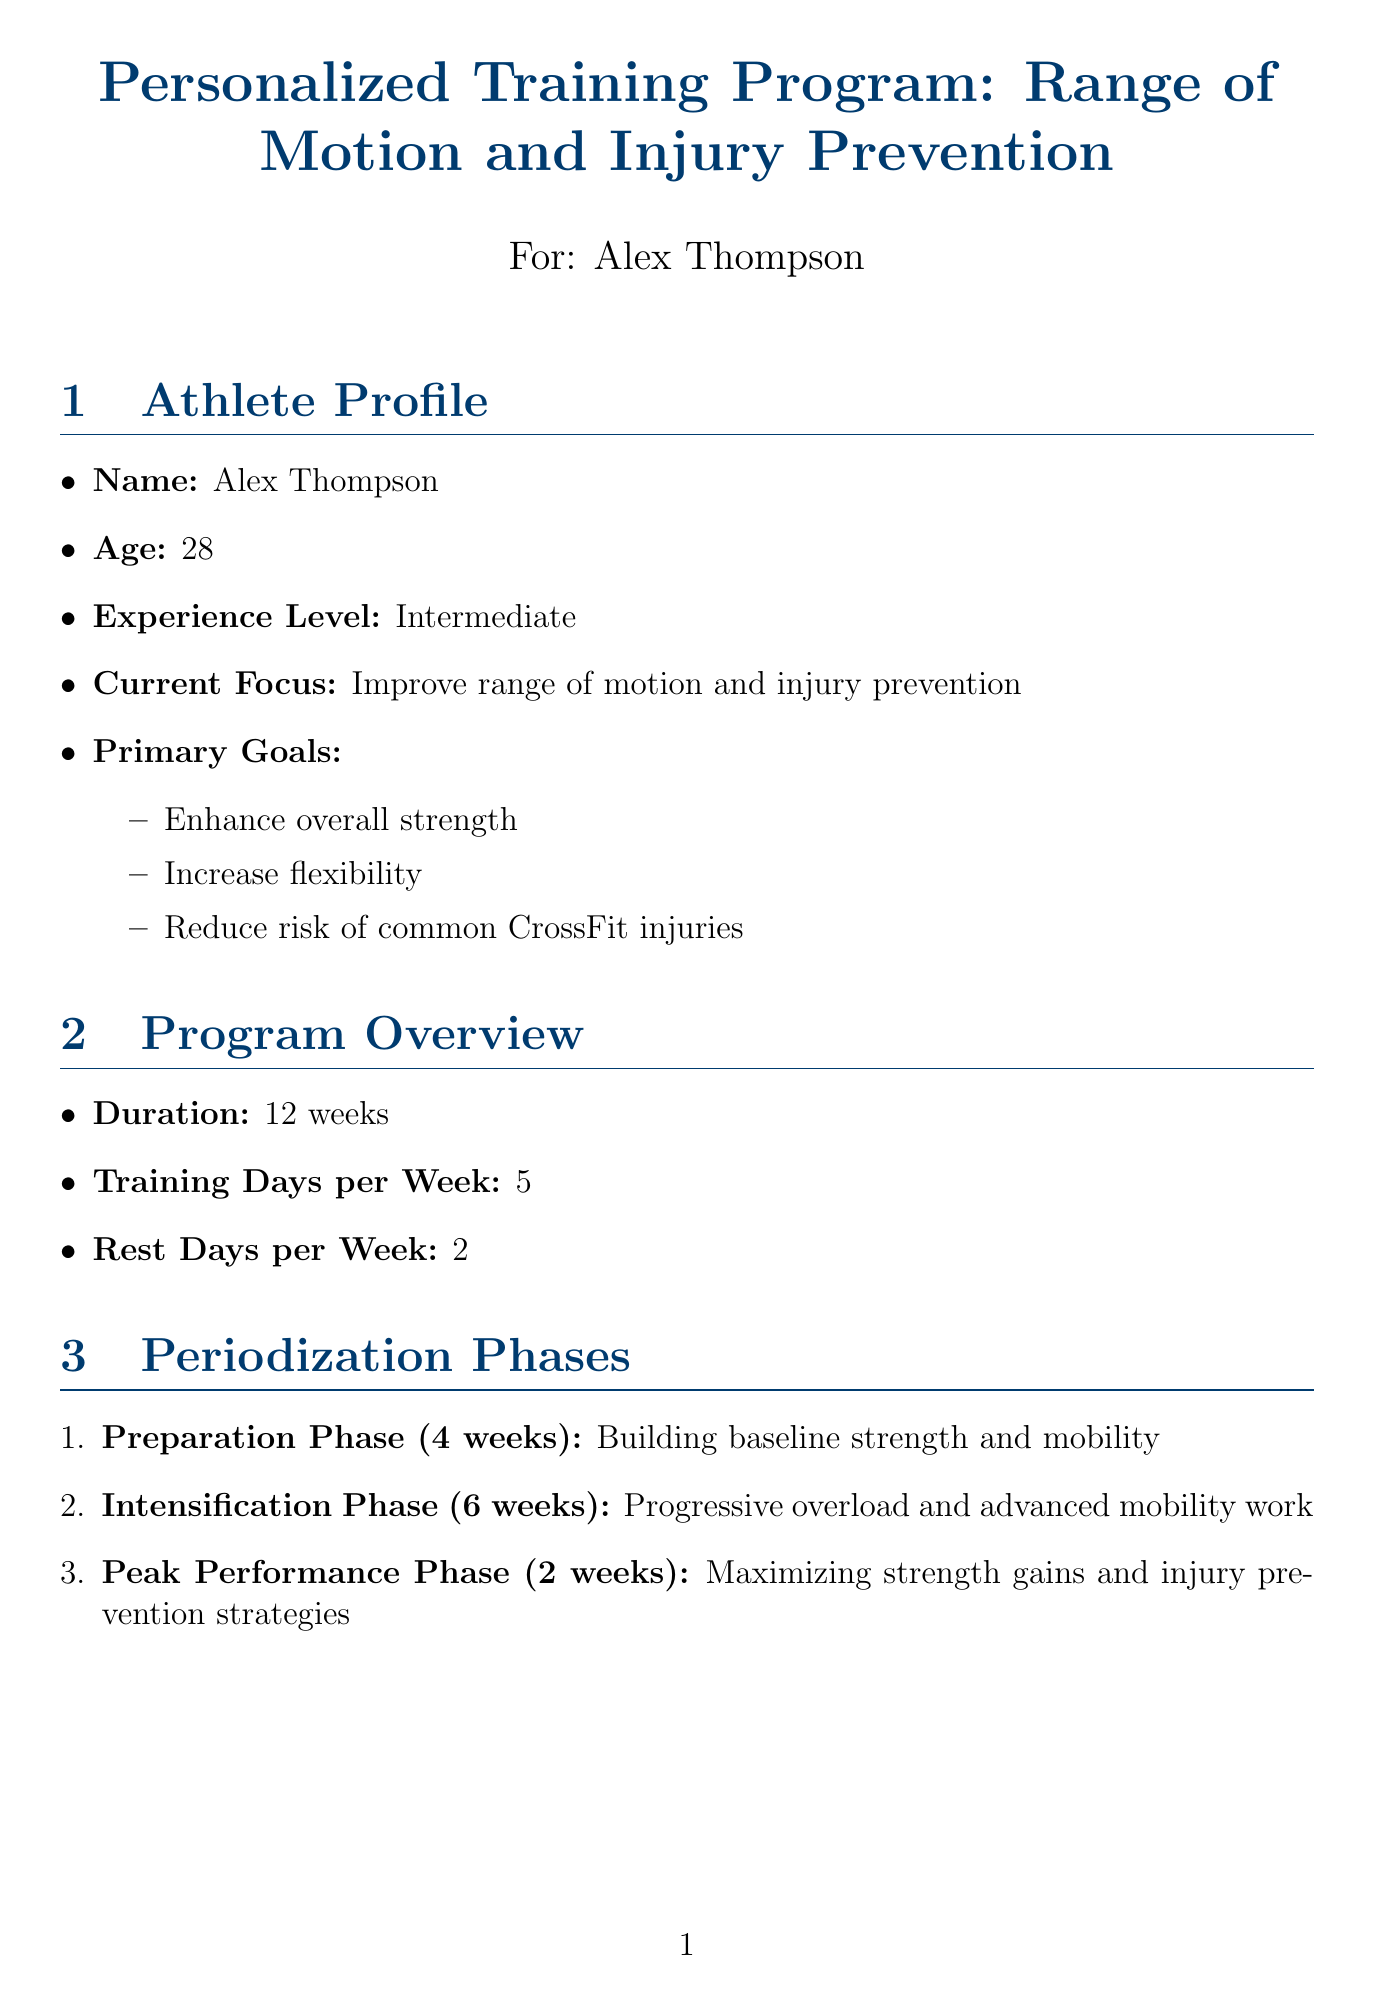What is the athlete's name? The athlete's name is listed in the athlete profile section of the document.
Answer: Alex Thompson How long is the entire training program? The training program's duration is indicated in the program overview section.
Answer: 12 weeks How many training days are there per week? The program overview specifies the number of training days in each week.
Answer: 5 What is the focus of the Intensification Phase? This phase's focus can be found in the periodization phases section of the document.
Answer: Progressive overload and advanced mobility work How often should Pigeon pose be performed? The frequency of this exercise is detailed in the specific exercises section under mobility work.
Answer: Daily What is one type of active recovery activity listed? The activities for active recovery can be found in the active recovery sessions section of the document.
Answer: Swimming What are the key supplements recommended? The document lists key supplements under the nutrition guidelines section.
Answer: Whey protein, Creatine monohydrate, Multivitamin, Fish oil How often should progress tracking occur? The frequency of progress tracking is mentioned in the progress tracking section of the document.
Answer: Every 4 weeks What is one injury prevention strategy mentioned? The document includes various strategies in the injury prevention strategies section.
Answer: Proper form analysis 